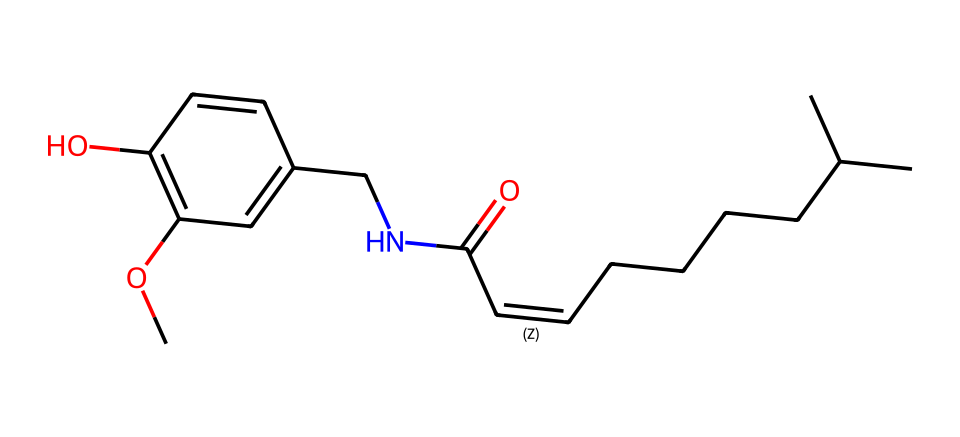How many carbon atoms are in the structure? By analyzing the SMILES representation, we can count the number of carbon atoms denoted by 'C'. There are 15 'C' characters in the SMILES which represent the carbon atoms in this molecule.
Answer: 15 What functional groups are present in this chemical? The SMILES shows the presence of a hydroxyl group (-OH) represented by 'O' adjacent to a carbon ('C'), and an ether functional group (-O-) indicated in the structure as well. Additionally, the presence of the carbonyl group (=O) and an amine (-N-) suggests that this molecule contains multiple functional groups.
Answer: alcohol, ether, carbonyl, amine Which type of bond primarily connects the carbon atoms in the chain? The predominant type of bond connecting the carbon atoms in this chain, particularly between the aliphatic portions shown in the SMILES string, is a single covalent bond signified by 'C-C'. The presence of a double bond (indicated by '=') in the chain also contributes.
Answer: single covalent bond How many rings are there in the structure? Looking through the SMILES representation, the main structural element doesn't show any closed loops or cyclic arrangements of atoms. All the connections depict an open-chain structure without any rings present.
Answer: 0 What property does the hydroxyl (-OH) group impart to this phenol? The hydroxyl group (-OH) in phenols typically contributes to their solubility in water and also increases acidity when compared to aliphatic hydrocarbons. The ability to form hydrogen bonds due to the presence of this group is also significant.
Answer: solubility, acidity What is the role of the amine (-N-) group in this molecule? The presence of the amine group (-N-) can indicate some level of basicity and connectivity to biological interactions, as amines can serve as proton acceptors or participate in hydrogen bonding, affecting the molecule's reactivity.
Answer: basicity Does this chemical structure exhibit any stereochemistry? The structure, as presented, includes a carbon-carbon double bond which can create geometric isomerism. Those groups attached to the double bond can have different spatial arrangements, indicating potential stereochemistry.
Answer: yes 